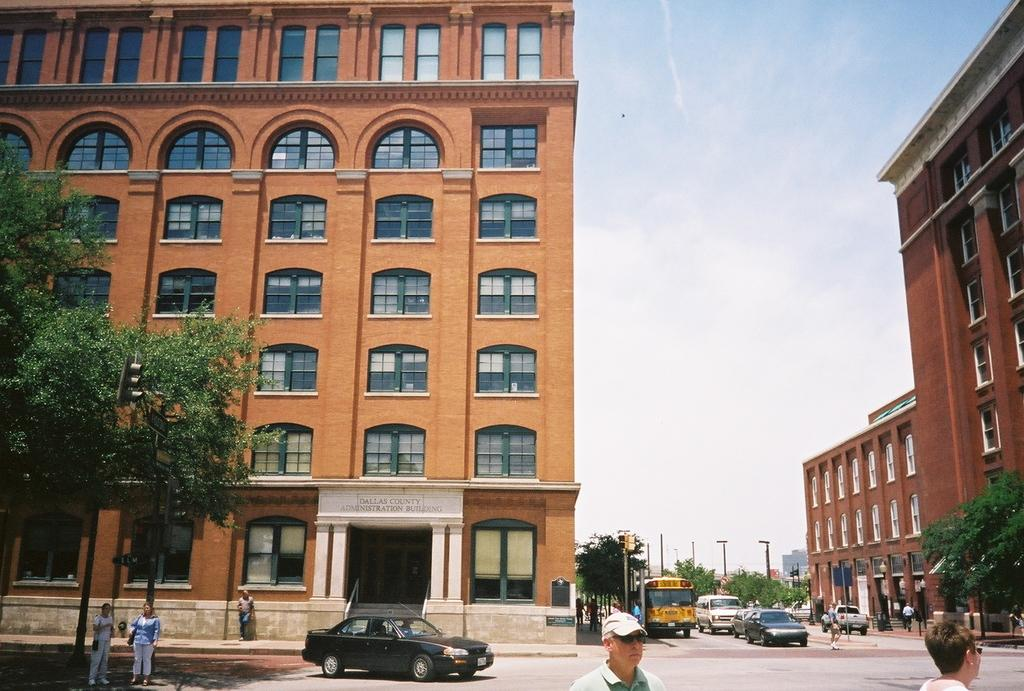What type of structures can be seen in the image? There are buildings in the image. What vehicles are present in the image? There are cars and a bus in the image in the image. Are there any individuals visible in the image? Yes, there are people standing in the image. What type of vegetation can be seen in the image? There are trees in the image. What is visible at the top of the image? The sky is visible at the top of the image. Can you see a veil on any of the people in the image? There is no veil present on any of the people in the image. What type of root system can be seen supporting the trees in the image? There is no root system visible in the image; only the trees themselves are visible. 